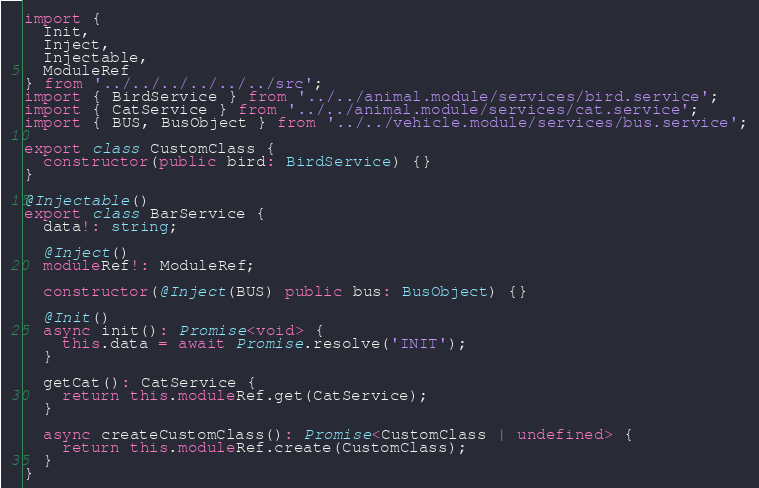Convert code to text. <code><loc_0><loc_0><loc_500><loc_500><_TypeScript_>import {
  Init,
  Inject,
  Injectable,
  ModuleRef
} from '../../../../../../src';
import { BirdService } from '../../animal.module/services/bird.service';
import { CatService } from '../../animal.module/services/cat.service';
import { BUS, BusObject } from '../../vehicle.module/services/bus.service';

export class CustomClass {
  constructor(public bird: BirdService) {}
}

@Injectable()
export class BarService {
  data!: string;

  @Inject()
  moduleRef!: ModuleRef;

  constructor(@Inject(BUS) public bus: BusObject) {}

  @Init()
  async init(): Promise<void> {
    this.data = await Promise.resolve('INIT');
  }

  getCat(): CatService {
    return this.moduleRef.get(CatService);
  }

  async createCustomClass(): Promise<CustomClass | undefined> {
    return this.moduleRef.create(CustomClass);
  }
}
</code> 